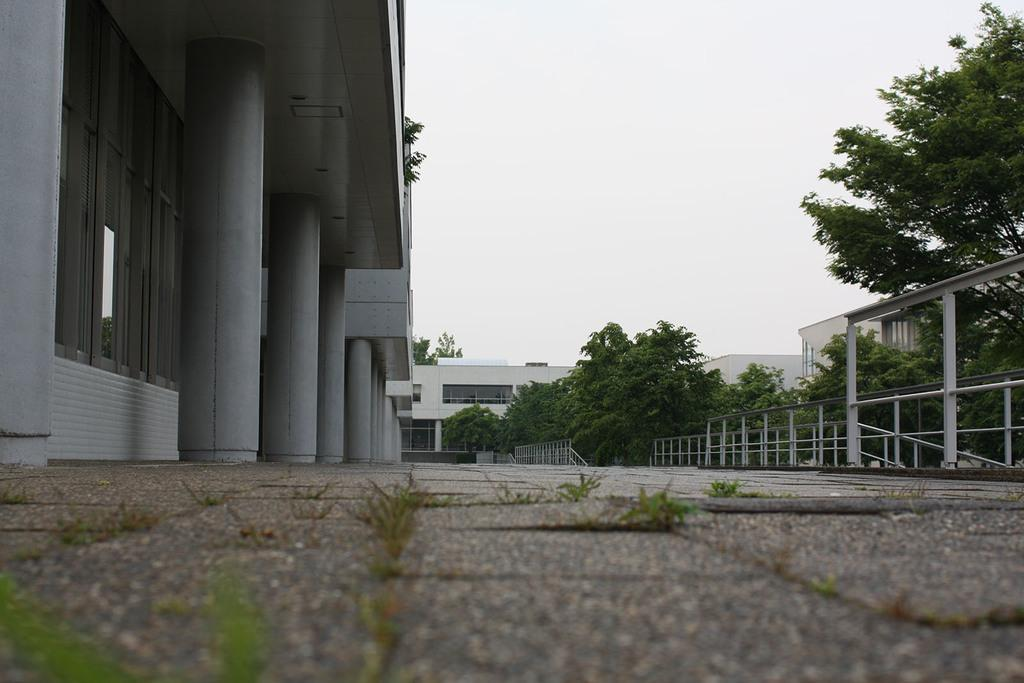What type of structures can be seen in the image? There are buildings in the image. What other natural elements are present in the image? There are trees in the image. What material is used for the rods visible in the image? Metal rods are visible in the image. How many ladybugs can be seen on the buildings in the image? There are no ladybugs present in the image; it only features buildings, trees, and metal rods. 